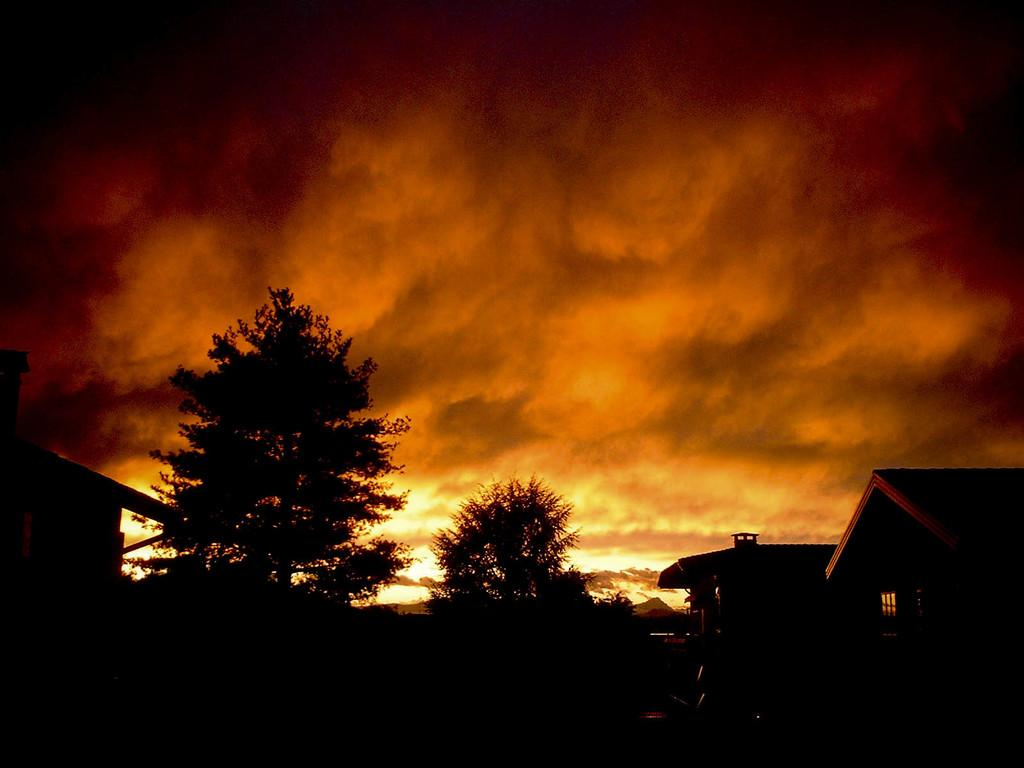What type of structures can be seen in the image? There are houses in the image. What other natural elements are present in the image? There are trees in the image. What is visible at the top of the image? The sky is visible at the top of the image. What can be observed in the sky? Clouds are present in the sky. What type of book is being read by the organization in the image? There is no organization or book present in the image; it features houses, trees, and a sky with clouds. 